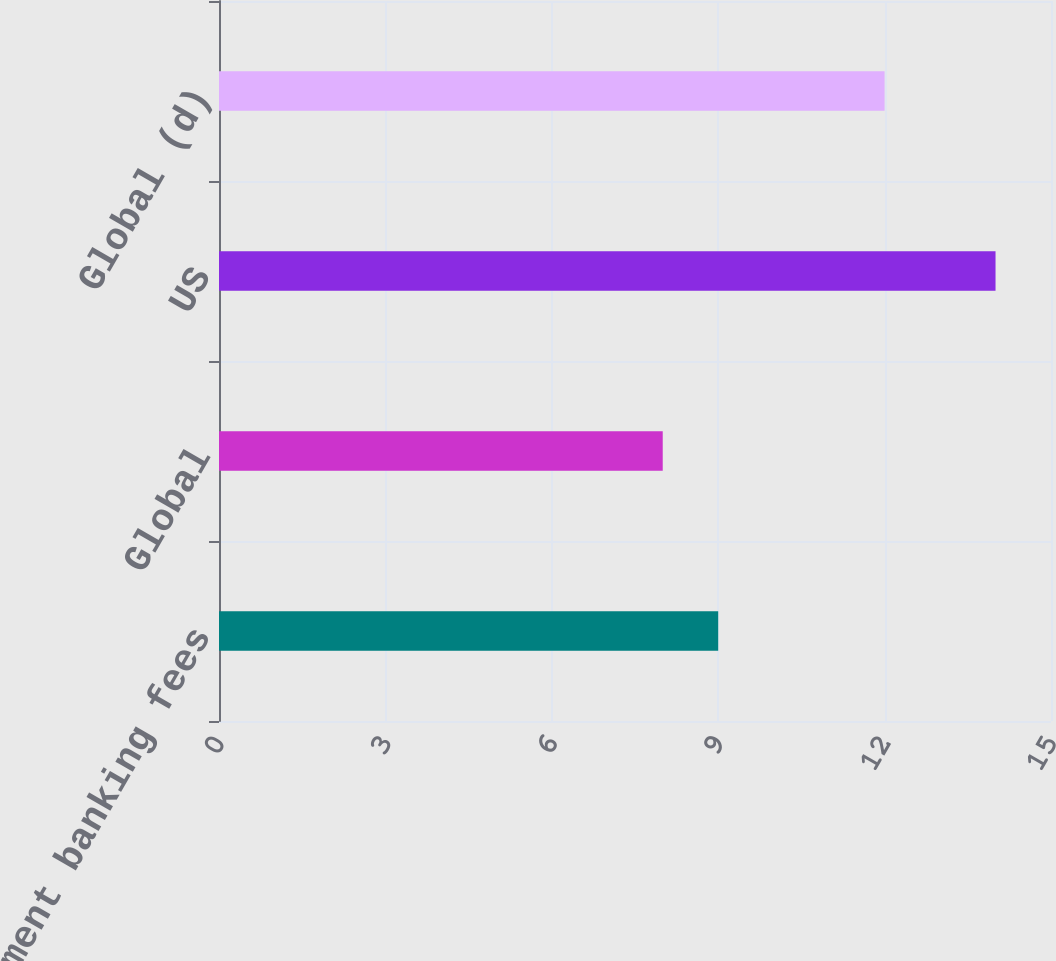Convert chart. <chart><loc_0><loc_0><loc_500><loc_500><bar_chart><fcel>Global investment banking fees<fcel>Global<fcel>US<fcel>Global (d)<nl><fcel>9<fcel>8<fcel>14<fcel>12<nl></chart> 